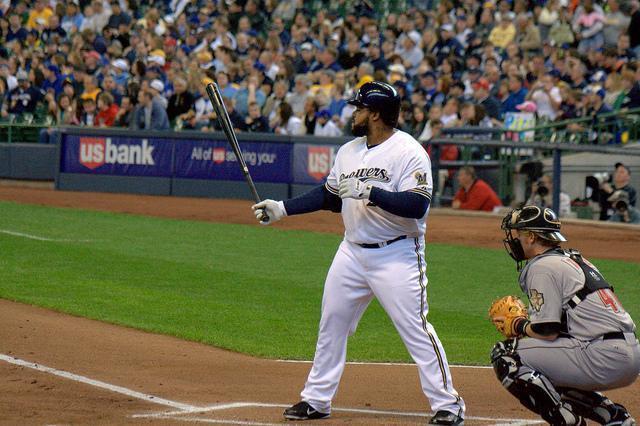How many baseball players are pictured?
Give a very brief answer. 2. How many empty seats are there?
Give a very brief answer. 0. How many people are there?
Give a very brief answer. 3. 